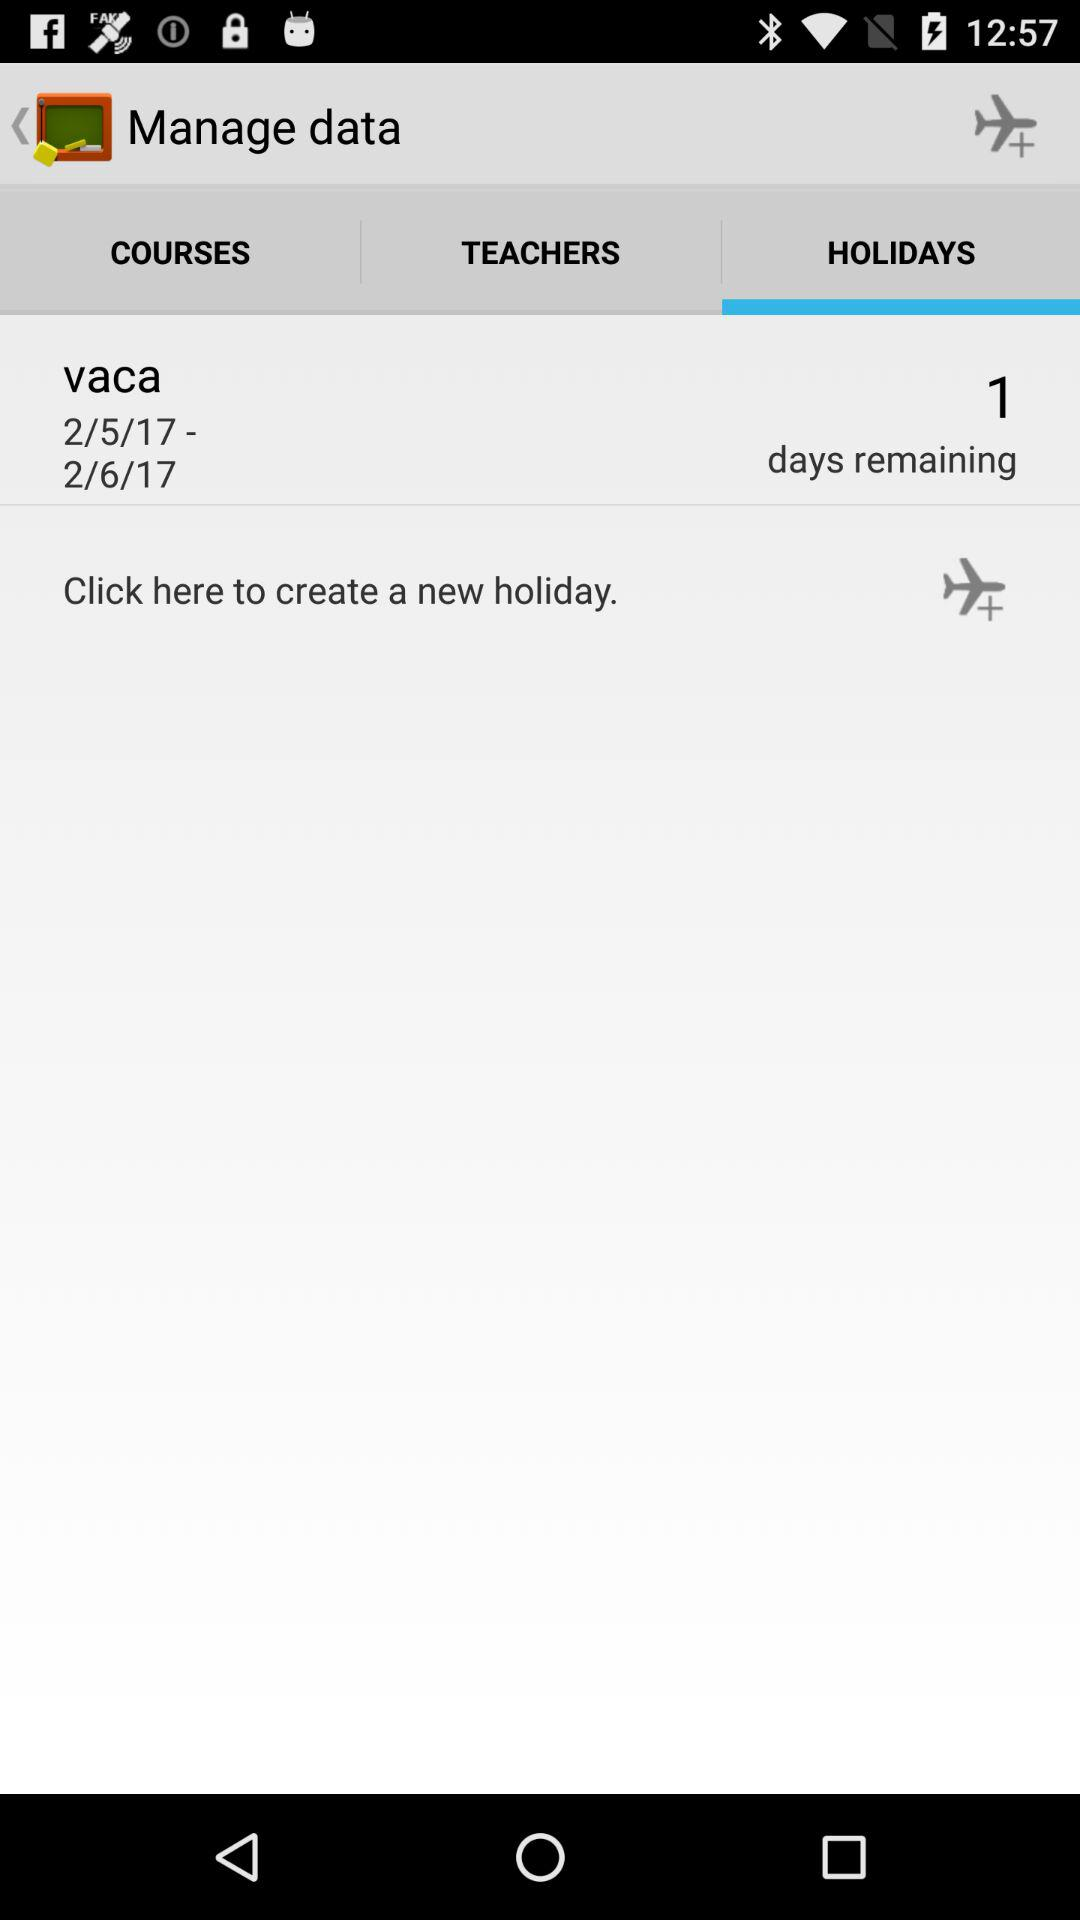Which tab is currently selected? The selected tab is "HOLIDAYS". 